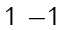Convert formula to latex. <formula><loc_0><loc_0><loc_500><loc_500>\begin{smallmatrix} 1 & - 1 \end{smallmatrix}</formula> 